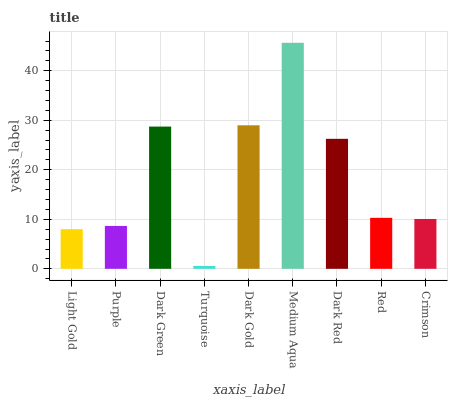Is Turquoise the minimum?
Answer yes or no. Yes. Is Medium Aqua the maximum?
Answer yes or no. Yes. Is Purple the minimum?
Answer yes or no. No. Is Purple the maximum?
Answer yes or no. No. Is Purple greater than Light Gold?
Answer yes or no. Yes. Is Light Gold less than Purple?
Answer yes or no. Yes. Is Light Gold greater than Purple?
Answer yes or no. No. Is Purple less than Light Gold?
Answer yes or no. No. Is Red the high median?
Answer yes or no. Yes. Is Red the low median?
Answer yes or no. Yes. Is Purple the high median?
Answer yes or no. No. Is Light Gold the low median?
Answer yes or no. No. 